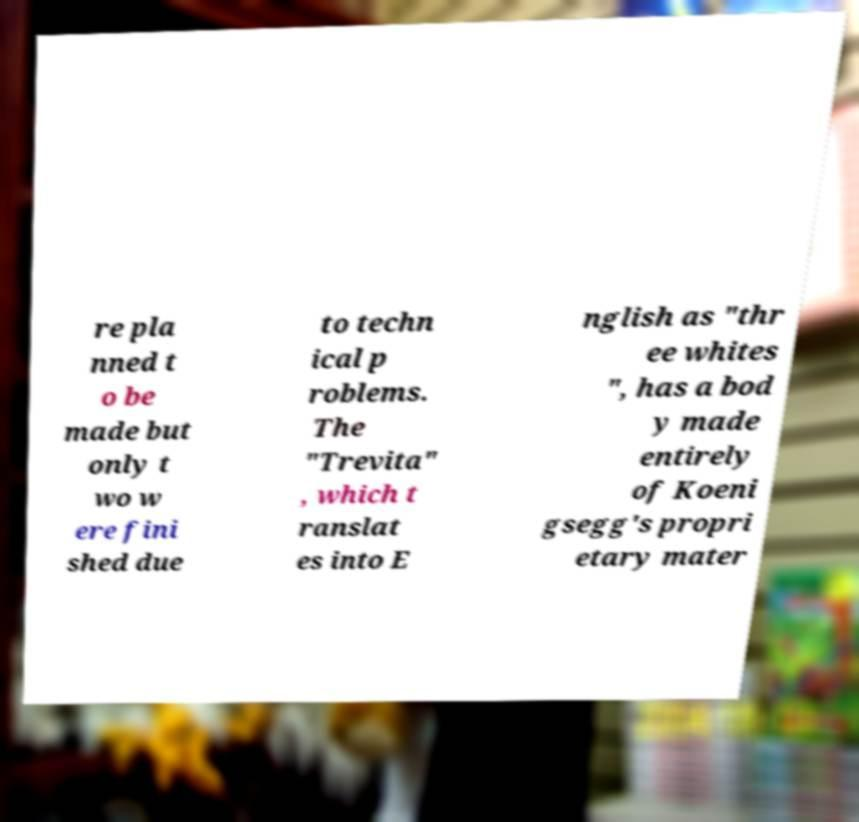Could you assist in decoding the text presented in this image and type it out clearly? re pla nned t o be made but only t wo w ere fini shed due to techn ical p roblems. The "Trevita" , which t ranslat es into E nglish as "thr ee whites ", has a bod y made entirely of Koeni gsegg's propri etary mater 